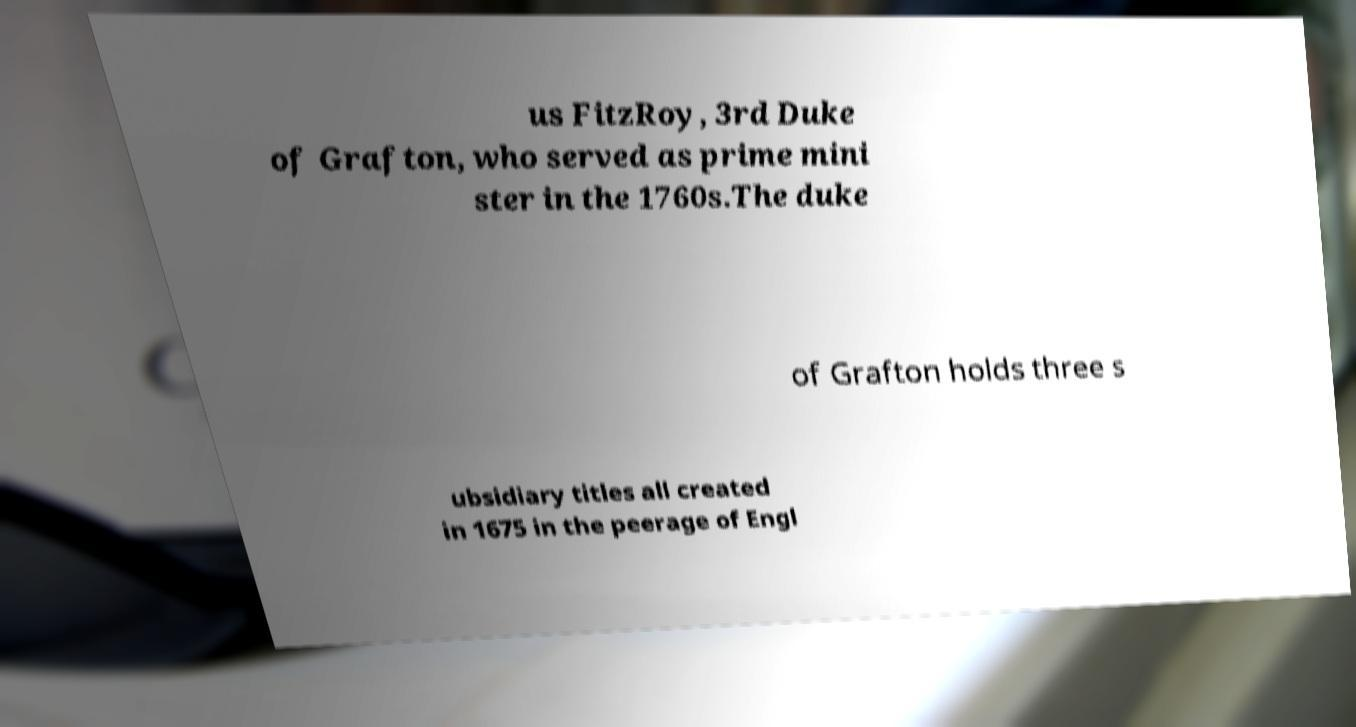What messages or text are displayed in this image? I need them in a readable, typed format. us FitzRoy, 3rd Duke of Grafton, who served as prime mini ster in the 1760s.The duke of Grafton holds three s ubsidiary titles all created in 1675 in the peerage of Engl 